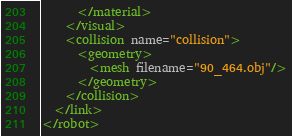<code> <loc_0><loc_0><loc_500><loc_500><_XML_>      </material>
    </visual>
    <collision name="collision">
      <geometry>
        <mesh filename="90_464.obj"/>
      </geometry>
    </collision>
  </link>
</robot>
</code> 